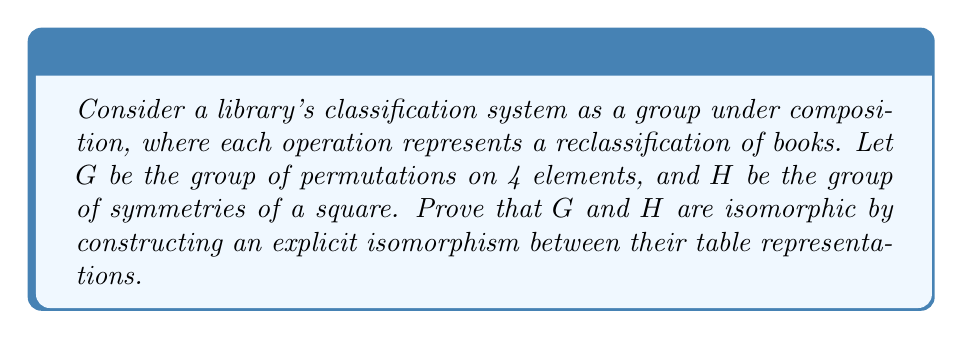Can you answer this question? To prove that the groups $G$ and $H$ are isomorphic, we need to construct a bijective homomorphism between them. We'll do this by showing their table representations are identical up to relabeling.

1) First, let's consider the group $G$ of permutations on 4 elements. This is isomorphic to $S_4$, which has 24 elements. We can represent these using cycle notation.

2) Now, consider the group $H$ of symmetries of a square. This group, often denoted $D_4$, also has 8 elements:
   - Identity (e)
   - 90° rotation clockwise (r)
   - 180° rotation (r^2)
   - 270° rotation clockwise (r^3)
   - Reflection about vertical axis (v)
   - Reflection about horizontal axis (h)
   - Reflection about main diagonal (d1)
   - Reflection about other diagonal (d2)

3) We can construct an isomorphism $\phi: G \to H$ as follows:
   $\phi(e) = e$
   $\phi((1234)) = r$
   $\phi((13)(24)) = r^2$
   $\phi((1432)) = r^3$
   $\phi((24)) = v$
   $\phi((13)) = h$
   $\phi((12)(34)) = d1$
   $\phi((14)(23)) = d2$

4) To prove this is an isomorphism, we need to show it preserves the group operation. We can do this by comparing the multiplication tables of $G$ and $H$ under this mapping.

5) For example, in $G$: $(1234) \circ (24) = (1432)$
   Under $\phi$, this becomes: $r \circ v = r^3$, which is true in $H$.

6) By systematically checking all possible combinations, we can verify that $\phi$ preserves the group operation for all elements.

7) Since $\phi$ is bijective (one-to-one and onto) and preserves the group operation, it is an isomorphism.

This isomorphism demonstrates that despite their different representations (permutations vs. symmetries), these groups have the same underlying structure, much like how different library classification systems might organize the same set of books in structurally equivalent ways.
Answer: The groups $G$ (permutations on 4 elements) and $H$ (symmetries of a square) are isomorphic. An explicit isomorphism $\phi: G \to H$ is given by:

$$\begin{align*}
\phi(e) &= e \\
\phi((1234)) &= r \\
\phi((13)(24)) &= r^2 \\
\phi((1432)) &= r^3 \\
\phi((24)) &= v \\
\phi((13)) &= h \\
\phi((12)(34)) &= d1 \\
\phi((14)(23)) &= d2
\end{align*}$$

This mapping preserves the group operation and is bijective, thus establishing the isomorphism between $G$ and $H$. 